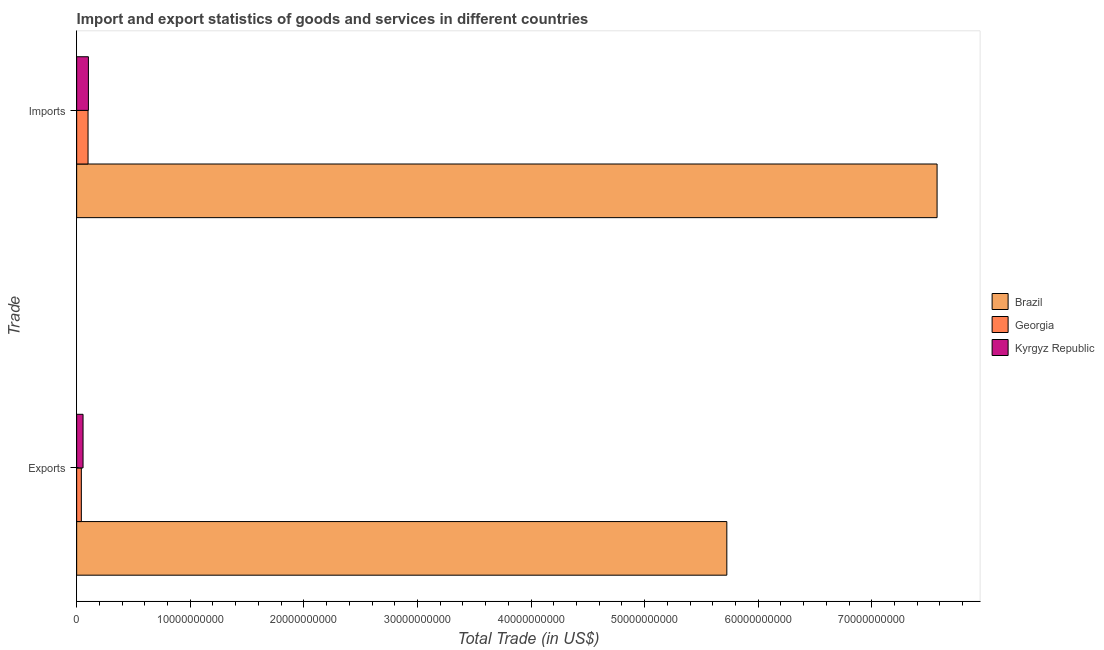How many different coloured bars are there?
Keep it short and to the point. 3. How many groups of bars are there?
Provide a succinct answer. 2. Are the number of bars per tick equal to the number of legend labels?
Offer a terse response. Yes. How many bars are there on the 2nd tick from the bottom?
Make the answer very short. 3. What is the label of the 1st group of bars from the top?
Your answer should be very brief. Imports. What is the imports of goods and services in Georgia?
Your answer should be very brief. 1.00e+09. Across all countries, what is the maximum imports of goods and services?
Your answer should be very brief. 7.57e+1. Across all countries, what is the minimum export of goods and services?
Make the answer very short. 4.12e+08. In which country was the export of goods and services minimum?
Your response must be concise. Georgia. What is the total export of goods and services in the graph?
Make the answer very short. 5.82e+1. What is the difference between the imports of goods and services in Georgia and that in Kyrgyz Republic?
Your answer should be compact. -3.18e+07. What is the difference between the export of goods and services in Brazil and the imports of goods and services in Kyrgyz Republic?
Provide a short and direct response. 5.62e+1. What is the average imports of goods and services per country?
Provide a succinct answer. 2.59e+1. What is the difference between the export of goods and services and imports of goods and services in Kyrgyz Republic?
Provide a succinct answer. -4.72e+08. In how many countries, is the export of goods and services greater than 16000000000 US$?
Keep it short and to the point. 1. What is the ratio of the export of goods and services in Georgia to that in Kyrgyz Republic?
Offer a very short reply. 0.73. What does the 3rd bar from the top in Imports represents?
Your answer should be very brief. Brazil. What does the 2nd bar from the bottom in Exports represents?
Ensure brevity in your answer.  Georgia. How many countries are there in the graph?
Offer a very short reply. 3. What is the difference between two consecutive major ticks on the X-axis?
Make the answer very short. 1.00e+1. Are the values on the major ticks of X-axis written in scientific E-notation?
Offer a very short reply. No. Does the graph contain any zero values?
Offer a very short reply. No. Does the graph contain grids?
Ensure brevity in your answer.  No. How many legend labels are there?
Your response must be concise. 3. What is the title of the graph?
Your answer should be compact. Import and export statistics of goods and services in different countries. What is the label or title of the X-axis?
Your answer should be compact. Total Trade (in US$). What is the label or title of the Y-axis?
Give a very brief answer. Trade. What is the Total Trade (in US$) in Brazil in Exports?
Offer a terse response. 5.72e+1. What is the Total Trade (in US$) in Georgia in Exports?
Offer a very short reply. 4.12e+08. What is the Total Trade (in US$) of Kyrgyz Republic in Exports?
Your response must be concise. 5.62e+08. What is the Total Trade (in US$) in Brazil in Imports?
Ensure brevity in your answer.  7.57e+1. What is the Total Trade (in US$) of Georgia in Imports?
Your answer should be compact. 1.00e+09. What is the Total Trade (in US$) of Kyrgyz Republic in Imports?
Your answer should be very brief. 1.03e+09. Across all Trade, what is the maximum Total Trade (in US$) in Brazil?
Keep it short and to the point. 7.57e+1. Across all Trade, what is the maximum Total Trade (in US$) in Georgia?
Your answer should be compact. 1.00e+09. Across all Trade, what is the maximum Total Trade (in US$) of Kyrgyz Republic?
Provide a short and direct response. 1.03e+09. Across all Trade, what is the minimum Total Trade (in US$) in Brazil?
Keep it short and to the point. 5.72e+1. Across all Trade, what is the minimum Total Trade (in US$) of Georgia?
Offer a very short reply. 4.12e+08. Across all Trade, what is the minimum Total Trade (in US$) of Kyrgyz Republic?
Keep it short and to the point. 5.62e+08. What is the total Total Trade (in US$) in Brazil in the graph?
Your answer should be compact. 1.33e+11. What is the total Total Trade (in US$) in Georgia in the graph?
Your response must be concise. 1.41e+09. What is the total Total Trade (in US$) in Kyrgyz Republic in the graph?
Give a very brief answer. 1.60e+09. What is the difference between the Total Trade (in US$) in Brazil in Exports and that in Imports?
Keep it short and to the point. -1.85e+1. What is the difference between the Total Trade (in US$) of Georgia in Exports and that in Imports?
Keep it short and to the point. -5.89e+08. What is the difference between the Total Trade (in US$) in Kyrgyz Republic in Exports and that in Imports?
Your response must be concise. -4.72e+08. What is the difference between the Total Trade (in US$) of Brazil in Exports and the Total Trade (in US$) of Georgia in Imports?
Provide a succinct answer. 5.62e+1. What is the difference between the Total Trade (in US$) of Brazil in Exports and the Total Trade (in US$) of Kyrgyz Republic in Imports?
Provide a succinct answer. 5.62e+1. What is the difference between the Total Trade (in US$) in Georgia in Exports and the Total Trade (in US$) in Kyrgyz Republic in Imports?
Make the answer very short. -6.21e+08. What is the average Total Trade (in US$) of Brazil per Trade?
Ensure brevity in your answer.  6.65e+1. What is the average Total Trade (in US$) in Georgia per Trade?
Offer a very short reply. 7.07e+08. What is the average Total Trade (in US$) in Kyrgyz Republic per Trade?
Your answer should be compact. 7.98e+08. What is the difference between the Total Trade (in US$) of Brazil and Total Trade (in US$) of Georgia in Exports?
Offer a terse response. 5.68e+1. What is the difference between the Total Trade (in US$) of Brazil and Total Trade (in US$) of Kyrgyz Republic in Exports?
Keep it short and to the point. 5.67e+1. What is the difference between the Total Trade (in US$) in Georgia and Total Trade (in US$) in Kyrgyz Republic in Exports?
Give a very brief answer. -1.49e+08. What is the difference between the Total Trade (in US$) of Brazil and Total Trade (in US$) of Georgia in Imports?
Provide a succinct answer. 7.47e+1. What is the difference between the Total Trade (in US$) of Brazil and Total Trade (in US$) of Kyrgyz Republic in Imports?
Offer a very short reply. 7.47e+1. What is the difference between the Total Trade (in US$) in Georgia and Total Trade (in US$) in Kyrgyz Republic in Imports?
Make the answer very short. -3.18e+07. What is the ratio of the Total Trade (in US$) of Brazil in Exports to that in Imports?
Offer a very short reply. 0.76. What is the ratio of the Total Trade (in US$) in Georgia in Exports to that in Imports?
Offer a terse response. 0.41. What is the ratio of the Total Trade (in US$) of Kyrgyz Republic in Exports to that in Imports?
Your answer should be very brief. 0.54. What is the difference between the highest and the second highest Total Trade (in US$) in Brazil?
Your answer should be compact. 1.85e+1. What is the difference between the highest and the second highest Total Trade (in US$) in Georgia?
Give a very brief answer. 5.89e+08. What is the difference between the highest and the second highest Total Trade (in US$) in Kyrgyz Republic?
Provide a succinct answer. 4.72e+08. What is the difference between the highest and the lowest Total Trade (in US$) of Brazil?
Your response must be concise. 1.85e+1. What is the difference between the highest and the lowest Total Trade (in US$) of Georgia?
Make the answer very short. 5.89e+08. What is the difference between the highest and the lowest Total Trade (in US$) of Kyrgyz Republic?
Make the answer very short. 4.72e+08. 